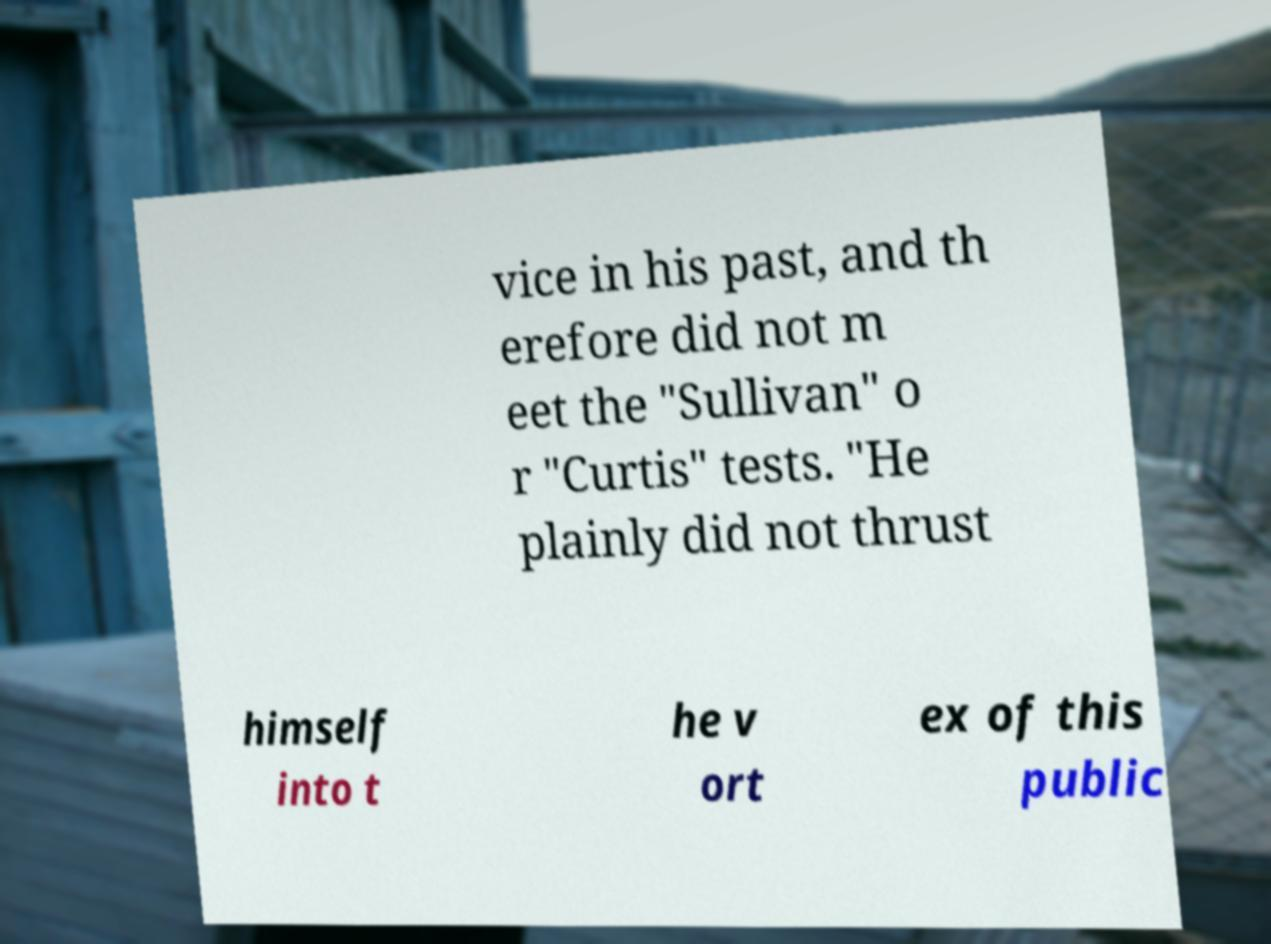Can you accurately transcribe the text from the provided image for me? vice in his past, and th erefore did not m eet the "Sullivan" o r "Curtis" tests. "He plainly did not thrust himself into t he v ort ex of this public 